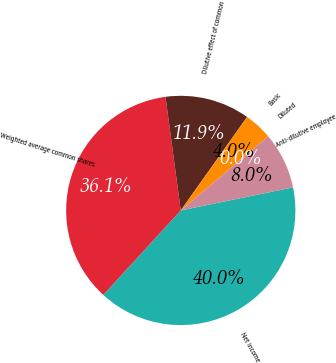Convert chart. <chart><loc_0><loc_0><loc_500><loc_500><pie_chart><fcel>Net income<fcel>Weighted average common shares<fcel>Dilutive effect of common<fcel>Basic<fcel>Diluted<fcel>Anti-dilutive employee<nl><fcel>40.04%<fcel>36.06%<fcel>11.95%<fcel>3.98%<fcel>0.0%<fcel>7.97%<nl></chart> 